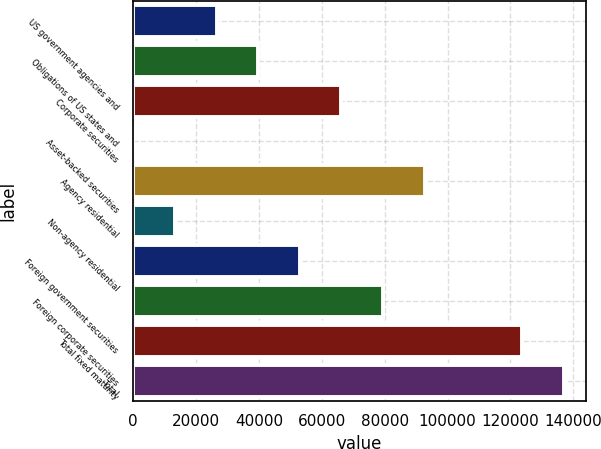Convert chart. <chart><loc_0><loc_0><loc_500><loc_500><bar_chart><fcel>US government agencies and<fcel>Obligations of US states and<fcel>Corporate securities<fcel>Asset-backed securities<fcel>Agency residential<fcel>Non-agency residential<fcel>Foreign government securities<fcel>Foreign corporate securities<fcel>Total fixed maturity<fcel>Total<nl><fcel>26490.8<fcel>39733.2<fcel>66218<fcel>6<fcel>92702.8<fcel>13248.4<fcel>52975.6<fcel>79460.4<fcel>123833<fcel>137075<nl></chart> 